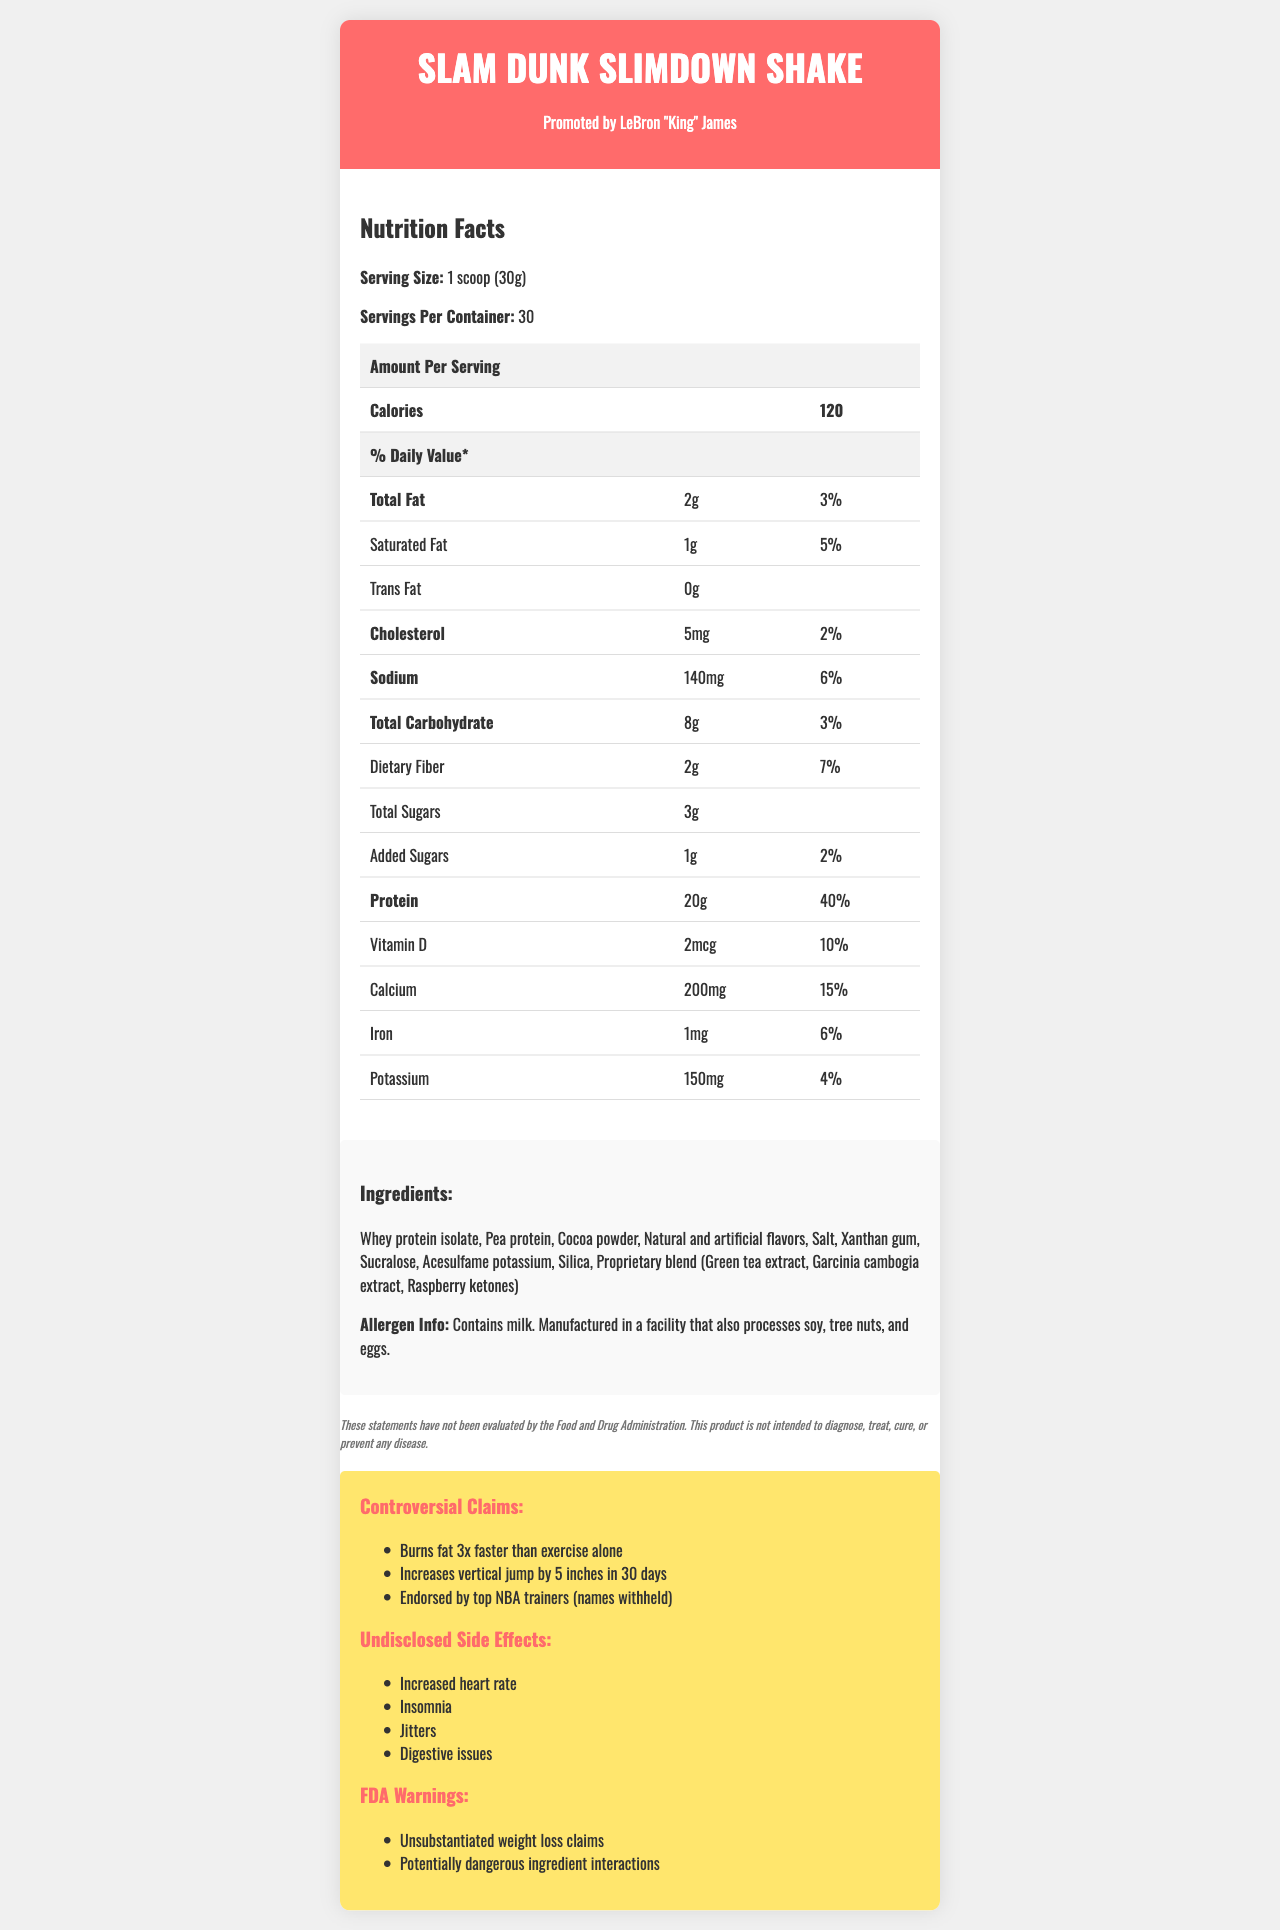what is the serving size? The label specifically states that the serving size for the Slam Dunk Slimdown Shake is 1 scoop (30g).
Answer: 1 scoop (30g) how many servings are there per container? The document mentions that there are 30 servings per container.
Answer: 30 what is the total fat content per serving? The total fat content per serving is listed as 2g on the label.
Answer: 2g what is the daily value percentage of protein? The document shows that the protein daily value percentage is 40%.
Answer: 40% how much sodium is in each serving? The label specifies that there are 140mg of sodium per serving.
Answer: 140mg what are the controversial claims made about this product? These claims are highlighted in the controversial claims section of the document.
Answer: Burns fat 3x faster than exercise alone, Increases vertical jump by 5 inches in 30 days, Endorsed by top NBA trainers (names withheld) how many milligrams of calcium does each serving contain? The document shows that each serving contains 200mg of calcium.
Answer: 200mg According to the document, how much cholesterol is in each serving? A. 0mg B. 5mg C. 10mg D. 20mg The nutrition facts indicate that there is 5mg of cholesterol per serving.
Answer: B which of the following ingredients is not listed? A. Sucralose B. Acesulfame potassium C. Stevia D. Silica Stevia is not listed in the ingredients section, whereas Sucralose, Acesulfame potassium, and Silica are.
Answer: C is there any cholesterol in this product? The nutrition facts list shows that there are 5mg of cholesterol per serving.
Answer: Yes does the document mention any side effects associated with this product? The document includes a section detailing undisclosed side effects: Increased heart rate, Insomnia, Jitters, Digestive issues.
Answer: Yes does the product have any FDA warnings? There are FDA warnings mentioned about unsubstantiated weight loss claims and potentially dangerous ingredient interactions.
Answer: Yes summarize the main idea of this document. The document gives a detailed overview of the Slam Dunk Slimdown Shake, its nutritional content, ingredients, allergen information, controversial claims, side effects, and FDA warnings, all highlighting the primary attributes and controversies of the product.
Answer: The Slam Dunk Slimdown Shake, promoted by LeBron "King" James, is a weight-loss shake with controversial claims of burning fat 3x faster than exercise alone and improving vertical jumps. It contains various ingredients and nutrients detailed in a nutrition facts label and a disclaimer that the product is not FDA evaluated. The document also highlights undisclosed side effects and FDA warnings about the product. are the trainers endorsing this product named in the document? The document mentions that the product is endorsed by top NBA trainers but their names are withheld, leaving this information unspecified.
Answer: No 